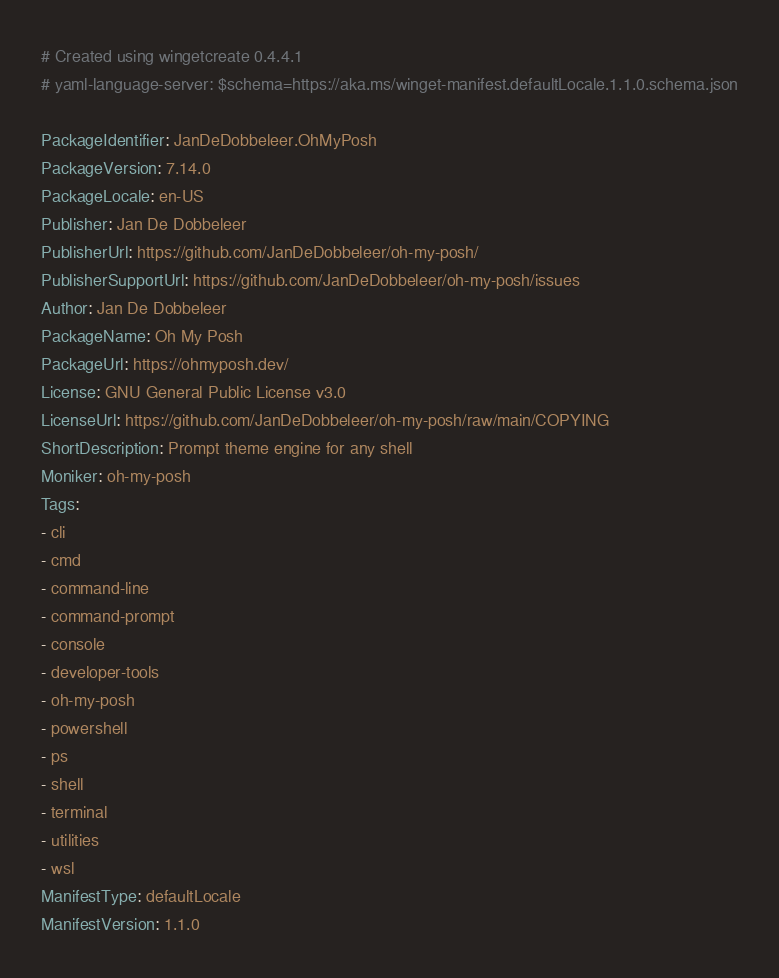Convert code to text. <code><loc_0><loc_0><loc_500><loc_500><_YAML_># Created using wingetcreate 0.4.4.1
# yaml-language-server: $schema=https://aka.ms/winget-manifest.defaultLocale.1.1.0.schema.json

PackageIdentifier: JanDeDobbeleer.OhMyPosh
PackageVersion: 7.14.0
PackageLocale: en-US
Publisher: Jan De Dobbeleer
PublisherUrl: https://github.com/JanDeDobbeleer/oh-my-posh/
PublisherSupportUrl: https://github.com/JanDeDobbeleer/oh-my-posh/issues
Author: Jan De Dobbeleer
PackageName: Oh My Posh
PackageUrl: https://ohmyposh.dev/
License: GNU General Public License v3.0
LicenseUrl: https://github.com/JanDeDobbeleer/oh-my-posh/raw/main/COPYING
ShortDescription: Prompt theme engine for any shell
Moniker: oh-my-posh
Tags:
- cli
- cmd
- command-line
- command-prompt
- console
- developer-tools
- oh-my-posh
- powershell
- ps
- shell
- terminal
- utilities
- wsl
ManifestType: defaultLocale
ManifestVersion: 1.1.0

</code> 